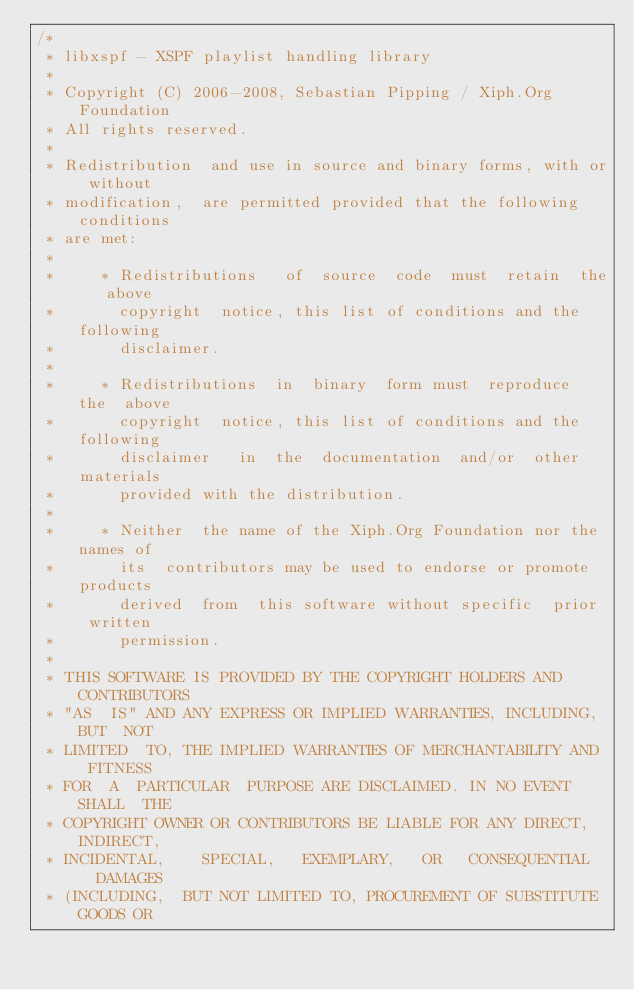Convert code to text. <code><loc_0><loc_0><loc_500><loc_500><_C++_>/*
 * libxspf - XSPF playlist handling library
 *
 * Copyright (C) 2006-2008, Sebastian Pipping / Xiph.Org Foundation
 * All rights reserved.
 *
 * Redistribution  and use in source and binary forms, with or without
 * modification,  are permitted provided that the following conditions
 * are met:
 *
 *     * Redistributions   of  source  code  must  retain  the   above
 *       copyright  notice, this list of conditions and the  following
 *       disclaimer.
 *
 *     * Redistributions  in  binary  form must  reproduce  the  above
 *       copyright  notice, this list of conditions and the  following
 *       disclaimer   in  the  documentation  and/or  other  materials
 *       provided with the distribution.
 *
 *     * Neither  the name of the Xiph.Org Foundation nor the names of
 *       its  contributors may be used to endorse or promote  products
 *       derived  from  this software without specific  prior  written
 *       permission.
 *
 * THIS SOFTWARE IS PROVIDED BY THE COPYRIGHT HOLDERS AND CONTRIBUTORS
 * "AS  IS" AND ANY EXPRESS OR IMPLIED WARRANTIES, INCLUDING, BUT  NOT
 * LIMITED  TO, THE IMPLIED WARRANTIES OF MERCHANTABILITY AND  FITNESS
 * FOR  A  PARTICULAR  PURPOSE ARE DISCLAIMED. IN NO EVENT  SHALL  THE
 * COPYRIGHT OWNER OR CONTRIBUTORS BE LIABLE FOR ANY DIRECT, INDIRECT,
 * INCIDENTAL,    SPECIAL,   EXEMPLARY,   OR   CONSEQUENTIAL   DAMAGES
 * (INCLUDING,  BUT NOT LIMITED TO, PROCUREMENT OF SUBSTITUTE GOODS OR</code> 